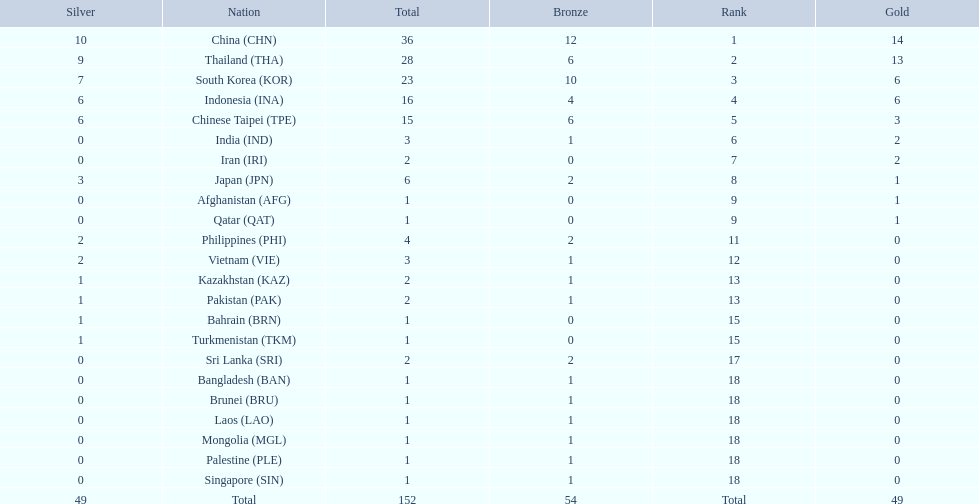How many nations received more than 5 gold medals? 4. Would you be able to parse every entry in this table? {'header': ['Silver', 'Nation', 'Total', 'Bronze', 'Rank', 'Gold'], 'rows': [['10', 'China\xa0(CHN)', '36', '12', '1', '14'], ['9', 'Thailand\xa0(THA)', '28', '6', '2', '13'], ['7', 'South Korea\xa0(KOR)', '23', '10', '3', '6'], ['6', 'Indonesia\xa0(INA)', '16', '4', '4', '6'], ['6', 'Chinese Taipei\xa0(TPE)', '15', '6', '5', '3'], ['0', 'India\xa0(IND)', '3', '1', '6', '2'], ['0', 'Iran\xa0(IRI)', '2', '0', '7', '2'], ['3', 'Japan\xa0(JPN)', '6', '2', '8', '1'], ['0', 'Afghanistan\xa0(AFG)', '1', '0', '9', '1'], ['0', 'Qatar\xa0(QAT)', '1', '0', '9', '1'], ['2', 'Philippines\xa0(PHI)', '4', '2', '11', '0'], ['2', 'Vietnam\xa0(VIE)', '3', '1', '12', '0'], ['1', 'Kazakhstan\xa0(KAZ)', '2', '1', '13', '0'], ['1', 'Pakistan\xa0(PAK)', '2', '1', '13', '0'], ['1', 'Bahrain\xa0(BRN)', '1', '0', '15', '0'], ['1', 'Turkmenistan\xa0(TKM)', '1', '0', '15', '0'], ['0', 'Sri Lanka\xa0(SRI)', '2', '2', '17', '0'], ['0', 'Bangladesh\xa0(BAN)', '1', '1', '18', '0'], ['0', 'Brunei\xa0(BRU)', '1', '1', '18', '0'], ['0', 'Laos\xa0(LAO)', '1', '1', '18', '0'], ['0', 'Mongolia\xa0(MGL)', '1', '1', '18', '0'], ['0', 'Palestine\xa0(PLE)', '1', '1', '18', '0'], ['0', 'Singapore\xa0(SIN)', '1', '1', '18', '0'], ['49', 'Total', '152', '54', 'Total', '49']]} 